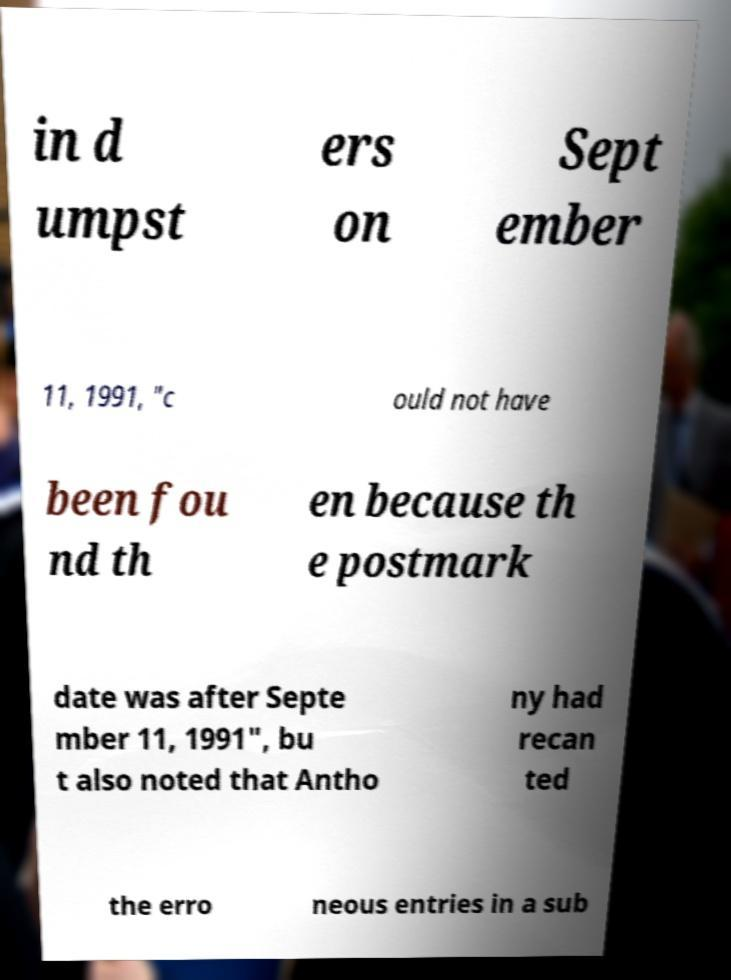What messages or text are displayed in this image? I need them in a readable, typed format. in d umpst ers on Sept ember 11, 1991, "c ould not have been fou nd th en because th e postmark date was after Septe mber 11, 1991", bu t also noted that Antho ny had recan ted the erro neous entries in a sub 